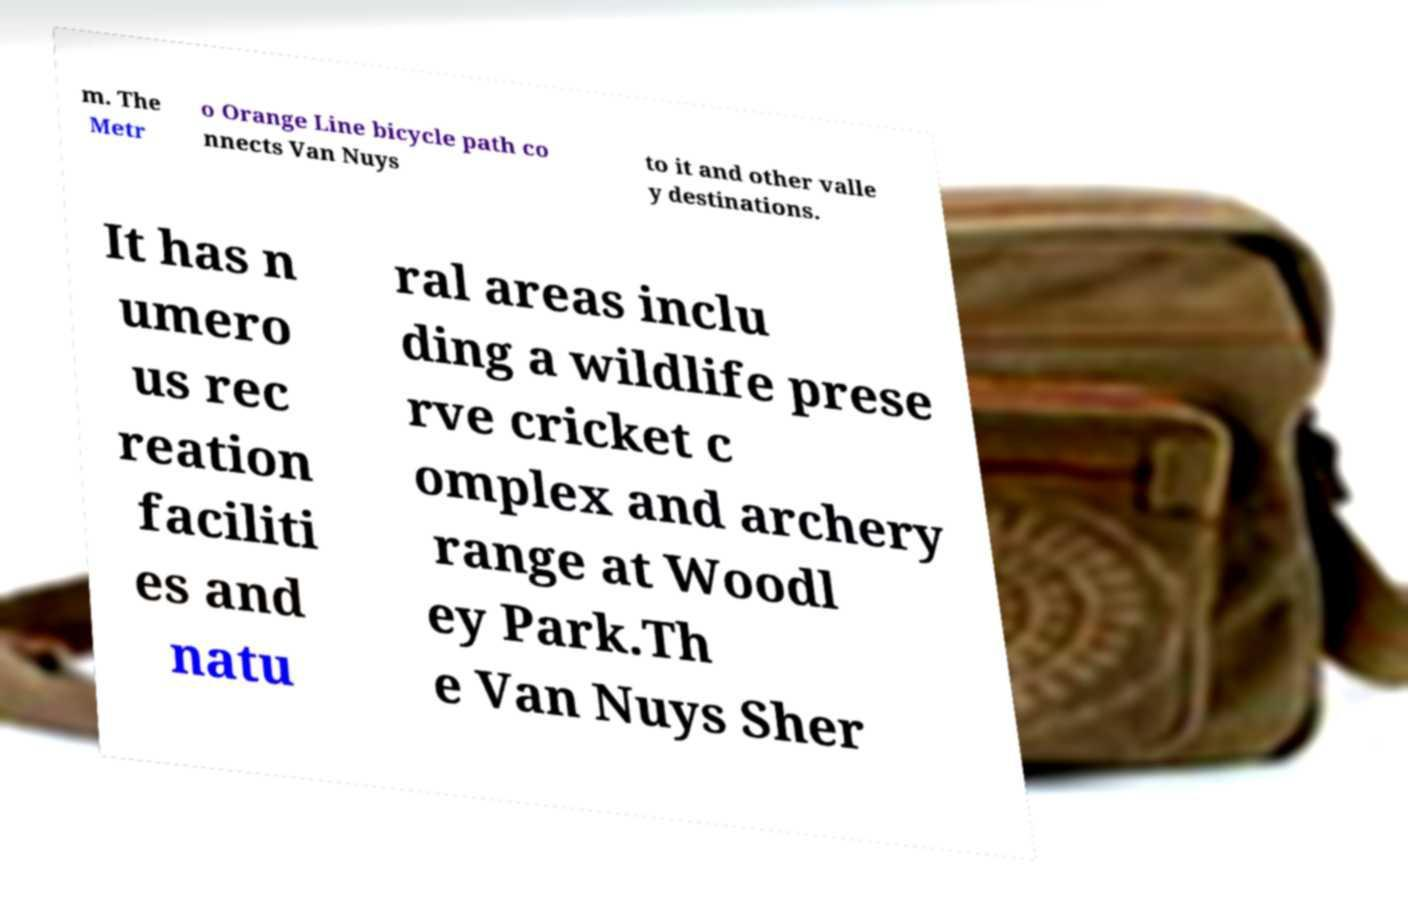What messages or text are displayed in this image? I need them in a readable, typed format. m. The Metr o Orange Line bicycle path co nnects Van Nuys to it and other valle y destinations. It has n umero us rec reation faciliti es and natu ral areas inclu ding a wildlife prese rve cricket c omplex and archery range at Woodl ey Park.Th e Van Nuys Sher 